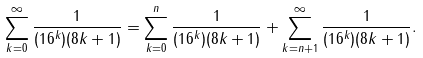<formula> <loc_0><loc_0><loc_500><loc_500>\sum _ { k = 0 } ^ { \infty } { \frac { 1 } { ( 1 6 ^ { k } ) ( 8 k + 1 ) } } = \sum _ { k = 0 } ^ { n } { \frac { 1 } { ( 1 6 ^ { k } ) ( 8 k + 1 ) } } + \sum _ { k = n + 1 } ^ { \infty } { \frac { 1 } { ( 1 6 ^ { k } ) ( 8 k + 1 ) } } .</formula> 